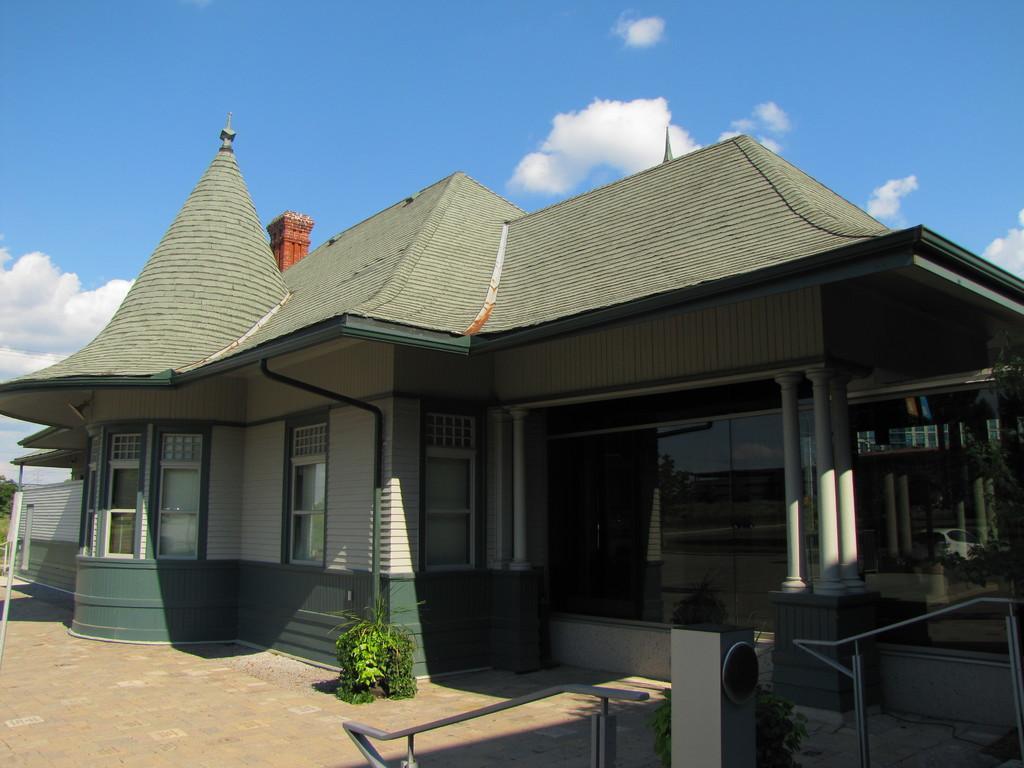How would you summarize this image in a sentence or two? In this image there is a building, in front of the building there is a plant. In the background there is the sky. 